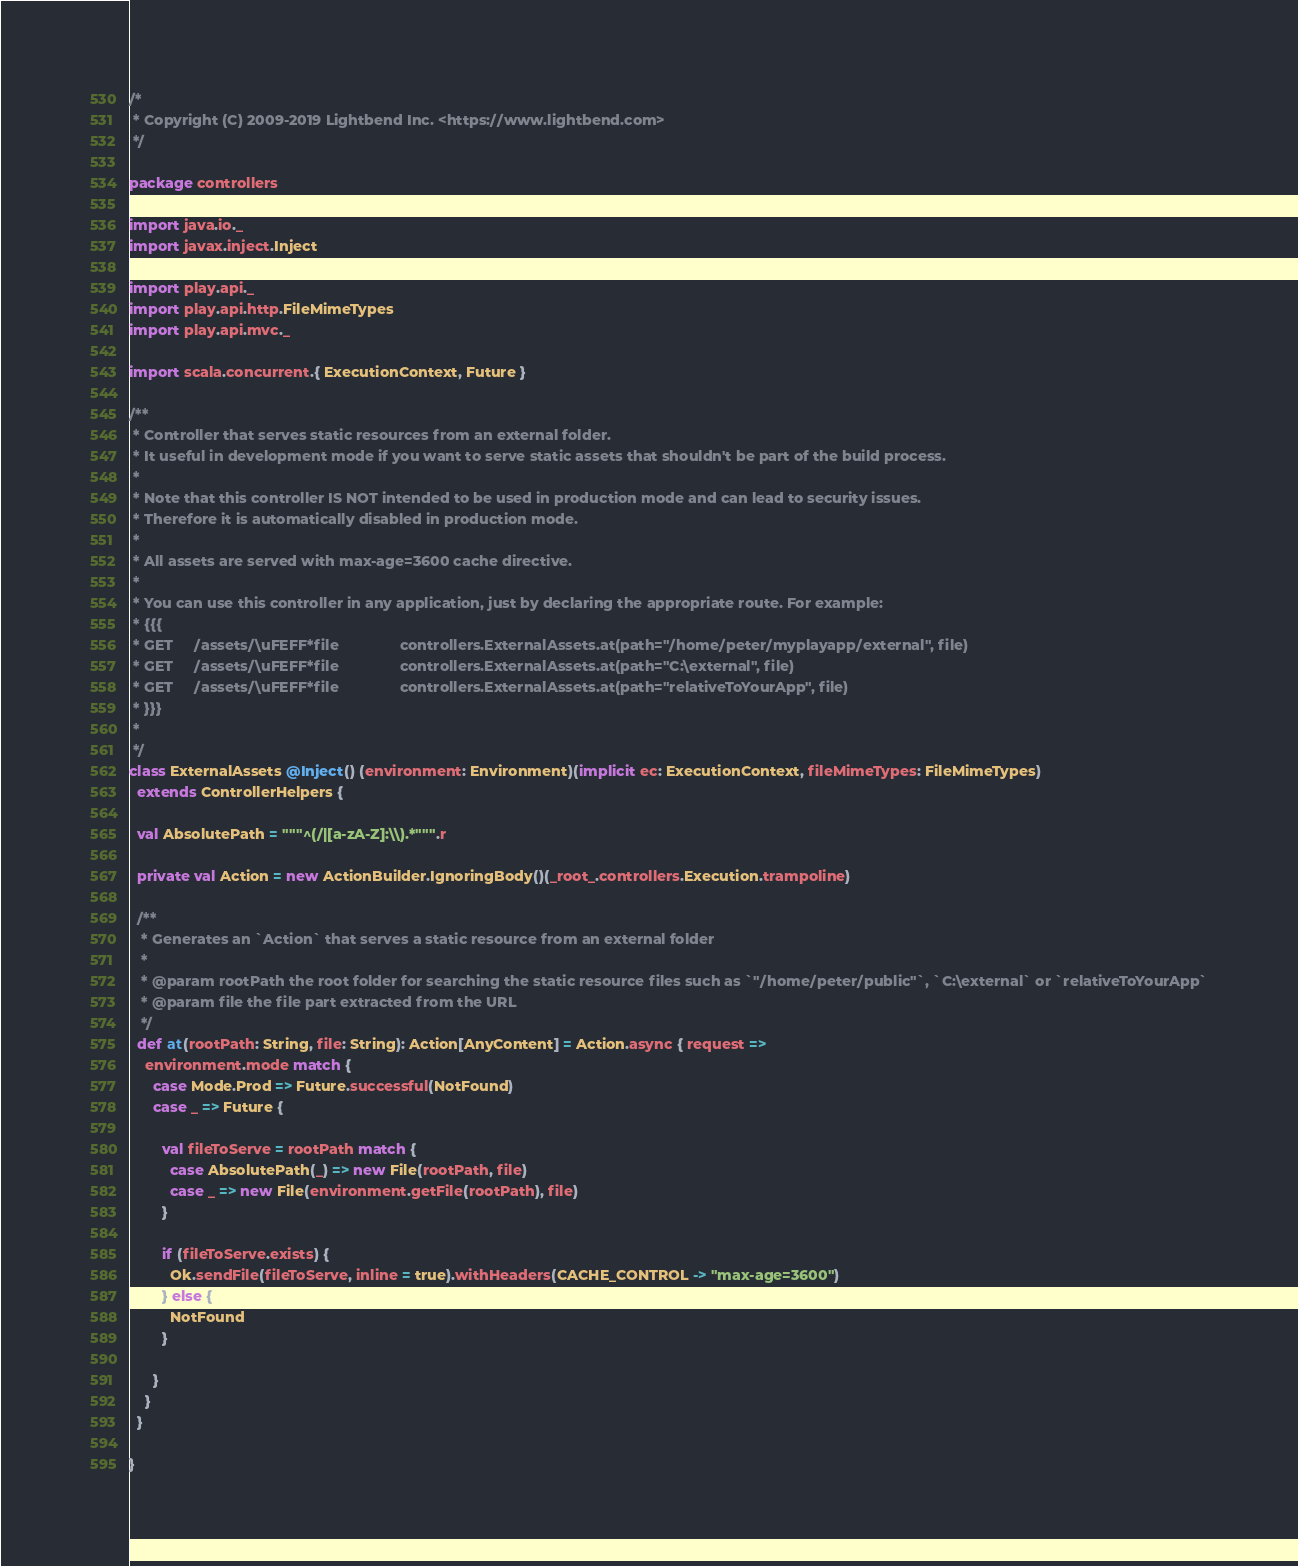Convert code to text. <code><loc_0><loc_0><loc_500><loc_500><_Scala_>/*
 * Copyright (C) 2009-2019 Lightbend Inc. <https://www.lightbend.com>
 */

package controllers

import java.io._
import javax.inject.Inject

import play.api._
import play.api.http.FileMimeTypes
import play.api.mvc._

import scala.concurrent.{ ExecutionContext, Future }

/**
 * Controller that serves static resources from an external folder.
 * It useful in development mode if you want to serve static assets that shouldn't be part of the build process.
 *
 * Note that this controller IS NOT intended to be used in production mode and can lead to security issues.
 * Therefore it is automatically disabled in production mode.
 *
 * All assets are served with max-age=3600 cache directive.
 *
 * You can use this controller in any application, just by declaring the appropriate route. For example:
 * {{{
 * GET     /assets/\uFEFF*file               controllers.ExternalAssets.at(path="/home/peter/myplayapp/external", file)
 * GET     /assets/\uFEFF*file               controllers.ExternalAssets.at(path="C:\external", file)
 * GET     /assets/\uFEFF*file               controllers.ExternalAssets.at(path="relativeToYourApp", file)
 * }}}
 *
 */
class ExternalAssets @Inject() (environment: Environment)(implicit ec: ExecutionContext, fileMimeTypes: FileMimeTypes)
  extends ControllerHelpers {

  val AbsolutePath = """^(/|[a-zA-Z]:\\).*""".r

  private val Action = new ActionBuilder.IgnoringBody()(_root_.controllers.Execution.trampoline)

  /**
   * Generates an `Action` that serves a static resource from an external folder
   *
   * @param rootPath the root folder for searching the static resource files such as `"/home/peter/public"`, `C:\external` or `relativeToYourApp`
   * @param file the file part extracted from the URL
   */
  def at(rootPath: String, file: String): Action[AnyContent] = Action.async { request =>
    environment.mode match {
      case Mode.Prod => Future.successful(NotFound)
      case _ => Future {

        val fileToServe = rootPath match {
          case AbsolutePath(_) => new File(rootPath, file)
          case _ => new File(environment.getFile(rootPath), file)
        }

        if (fileToServe.exists) {
          Ok.sendFile(fileToServe, inline = true).withHeaders(CACHE_CONTROL -> "max-age=3600")
        } else {
          NotFound
        }

      }
    }
  }

}
</code> 